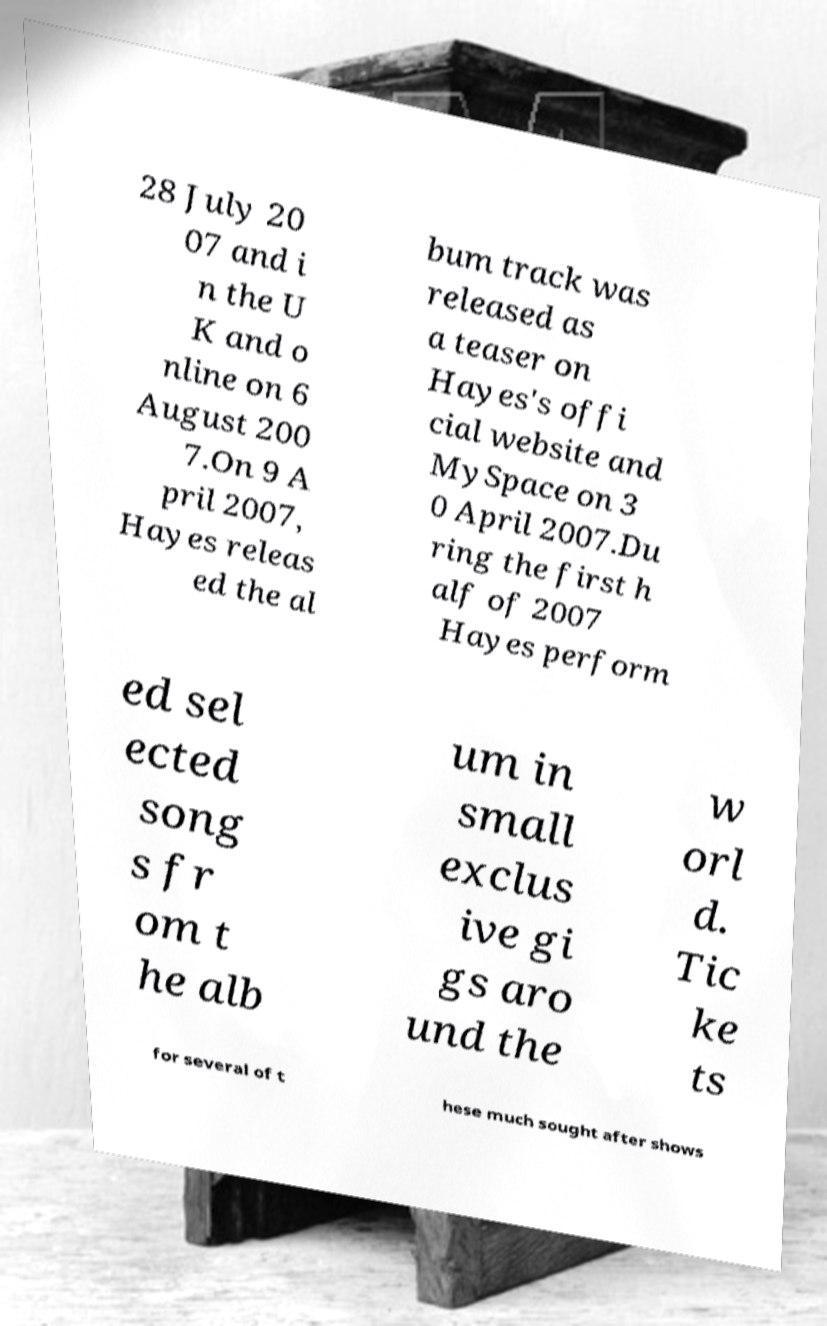I need the written content from this picture converted into text. Can you do that? 28 July 20 07 and i n the U K and o nline on 6 August 200 7.On 9 A pril 2007, Hayes releas ed the al bum track was released as a teaser on Hayes's offi cial website and MySpace on 3 0 April 2007.Du ring the first h alf of 2007 Hayes perform ed sel ected song s fr om t he alb um in small exclus ive gi gs aro und the w orl d. Tic ke ts for several of t hese much sought after shows 